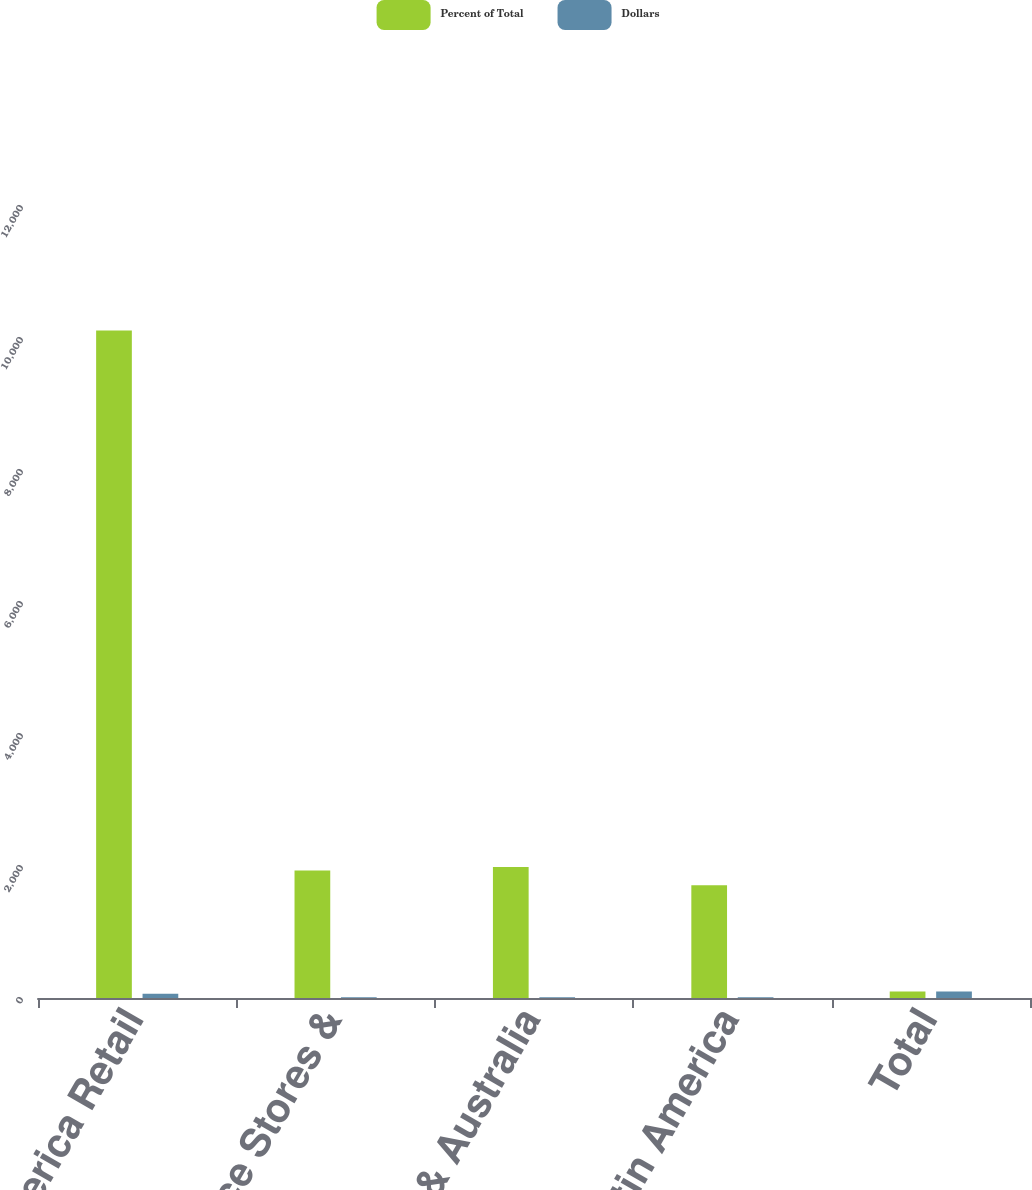<chart> <loc_0><loc_0><loc_500><loc_500><stacked_bar_chart><ecel><fcel>North America Retail<fcel>Convenience Stores &<fcel>Europe & Australia<fcel>Asia & Latin America<fcel>Total<nl><fcel>Percent of Total<fcel>10115.4<fcel>1930.2<fcel>1984.6<fcel>1710.2<fcel>100<nl><fcel>Dollars<fcel>64<fcel>12<fcel>13<fcel>11<fcel>100<nl></chart> 